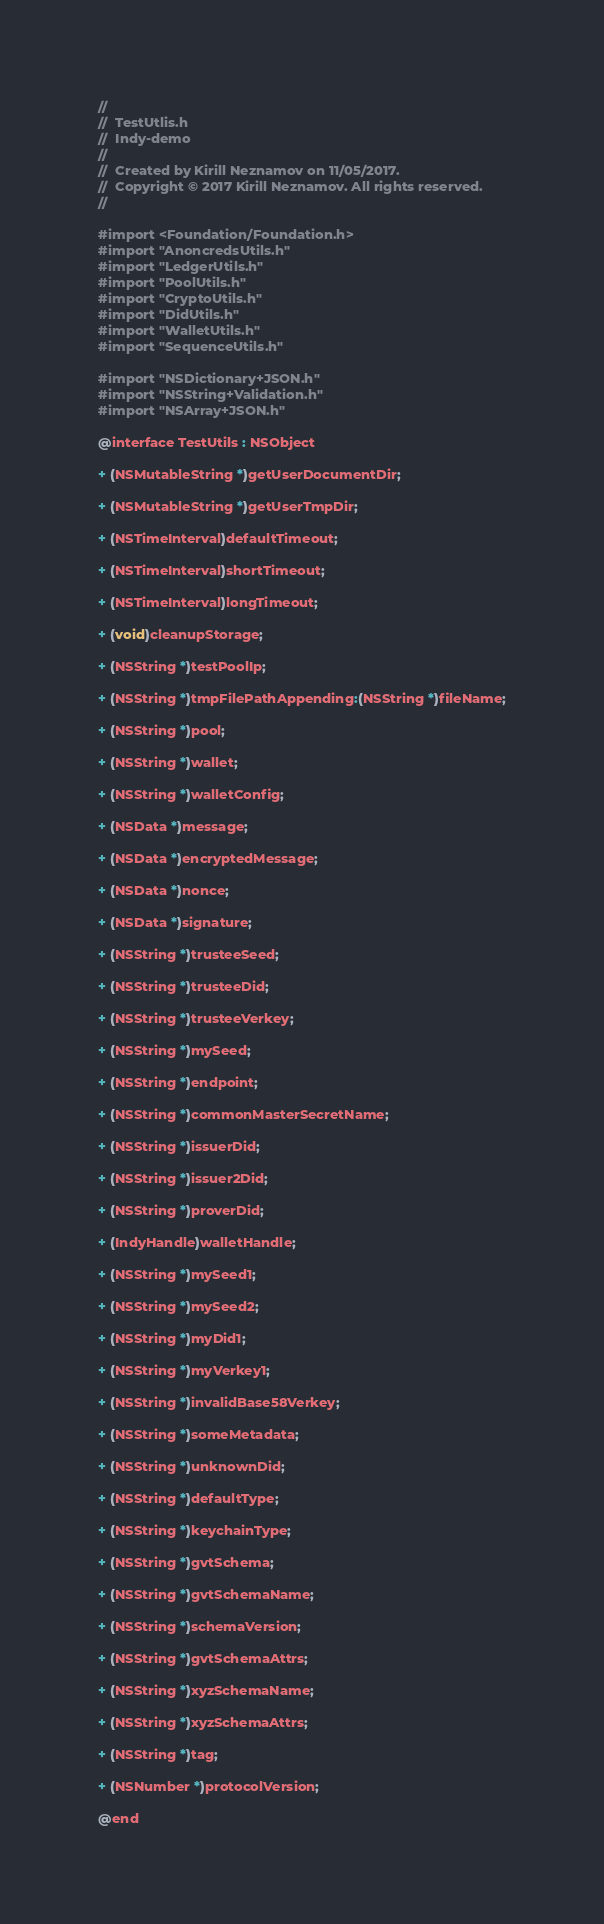<code> <loc_0><loc_0><loc_500><loc_500><_C_>//
//  TestUtlis.h
//  Indy-demo
//
//  Created by Kirill Neznamov on 11/05/2017.
//  Copyright © 2017 Kirill Neznamov. All rights reserved.
//

#import <Foundation/Foundation.h>
#import "AnoncredsUtils.h"
#import "LedgerUtils.h"
#import "PoolUtils.h"
#import "CryptoUtils.h"
#import "DidUtils.h"
#import "WalletUtils.h"
#import "SequenceUtils.h"

#import "NSDictionary+JSON.h"
#import "NSString+Validation.h"
#import "NSArray+JSON.h"

@interface TestUtils : NSObject

+ (NSMutableString *)getUserDocumentDir;

+ (NSMutableString *)getUserTmpDir;

+ (NSTimeInterval)defaultTimeout;

+ (NSTimeInterval)shortTimeout;

+ (NSTimeInterval)longTimeout;

+ (void)cleanupStorage;

+ (NSString *)testPoolIp;

+ (NSString *)tmpFilePathAppending:(NSString *)fileName;

+ (NSString *)pool;

+ (NSString *)wallet;

+ (NSString *)walletConfig;

+ (NSData *)message;

+ (NSData *)encryptedMessage;

+ (NSData *)nonce;

+ (NSData *)signature;

+ (NSString *)trusteeSeed;

+ (NSString *)trusteeDid;

+ (NSString *)trusteeVerkey;

+ (NSString *)mySeed;

+ (NSString *)endpoint;

+ (NSString *)commonMasterSecretName;

+ (NSString *)issuerDid;

+ (NSString *)issuer2Did;

+ (NSString *)proverDid;

+ (IndyHandle)walletHandle;

+ (NSString *)mySeed1;

+ (NSString *)mySeed2;

+ (NSString *)myDid1;

+ (NSString *)myVerkey1;

+ (NSString *)invalidBase58Verkey;

+ (NSString *)someMetadata;

+ (NSString *)unknownDid;

+ (NSString *)defaultType;

+ (NSString *)keychainType;

+ (NSString *)gvtSchema;

+ (NSString *)gvtSchemaName;

+ (NSString *)schemaVersion;

+ (NSString *)gvtSchemaAttrs;

+ (NSString *)xyzSchemaName;

+ (NSString *)xyzSchemaAttrs;

+ (NSString *)tag;

+ (NSNumber *)protocolVersion;

@end
</code> 